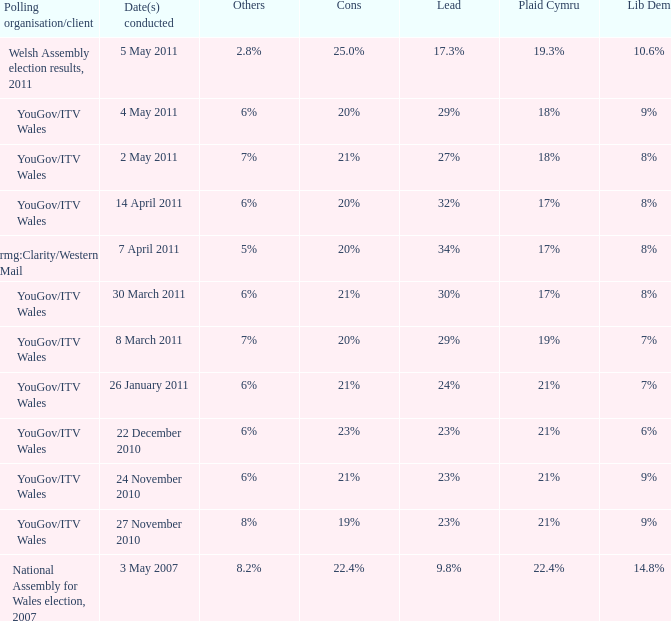Tell me the dates conducted for plaid cymru of 19% 8 March 2011. I'm looking to parse the entire table for insights. Could you assist me with that? {'header': ['Polling organisation/client', 'Date(s) conducted', 'Others', 'Cons', 'Lead', 'Plaid Cymru', 'Lib Dem'], 'rows': [['Welsh Assembly election results, 2011', '5 May 2011', '2.8%', '25.0%', '17.3%', '19.3%', '10.6%'], ['YouGov/ITV Wales', '4 May 2011', '6%', '20%', '29%', '18%', '9%'], ['YouGov/ITV Wales', '2 May 2011', '7%', '21%', '27%', '18%', '8%'], ['YouGov/ITV Wales', '14 April 2011', '6%', '20%', '32%', '17%', '8%'], ['rmg:Clarity/Western Mail', '7 April 2011', '5%', '20%', '34%', '17%', '8%'], ['YouGov/ITV Wales', '30 March 2011', '6%', '21%', '30%', '17%', '8%'], ['YouGov/ITV Wales', '8 March 2011', '7%', '20%', '29%', '19%', '7%'], ['YouGov/ITV Wales', '26 January 2011', '6%', '21%', '24%', '21%', '7%'], ['YouGov/ITV Wales', '22 December 2010', '6%', '23%', '23%', '21%', '6%'], ['YouGov/ITV Wales', '24 November 2010', '6%', '21%', '23%', '21%', '9%'], ['YouGov/ITV Wales', '27 November 2010', '8%', '19%', '23%', '21%', '9%'], ['National Assembly for Wales election, 2007', '3 May 2007', '8.2%', '22.4%', '9.8%', '22.4%', '14.8%']]} 